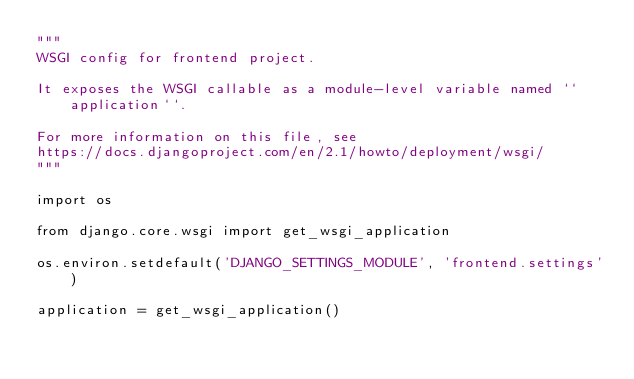<code> <loc_0><loc_0><loc_500><loc_500><_Python_>"""
WSGI config for frontend project.

It exposes the WSGI callable as a module-level variable named ``application``.

For more information on this file, see
https://docs.djangoproject.com/en/2.1/howto/deployment/wsgi/
"""

import os

from django.core.wsgi import get_wsgi_application

os.environ.setdefault('DJANGO_SETTINGS_MODULE', 'frontend.settings')

application = get_wsgi_application()
</code> 